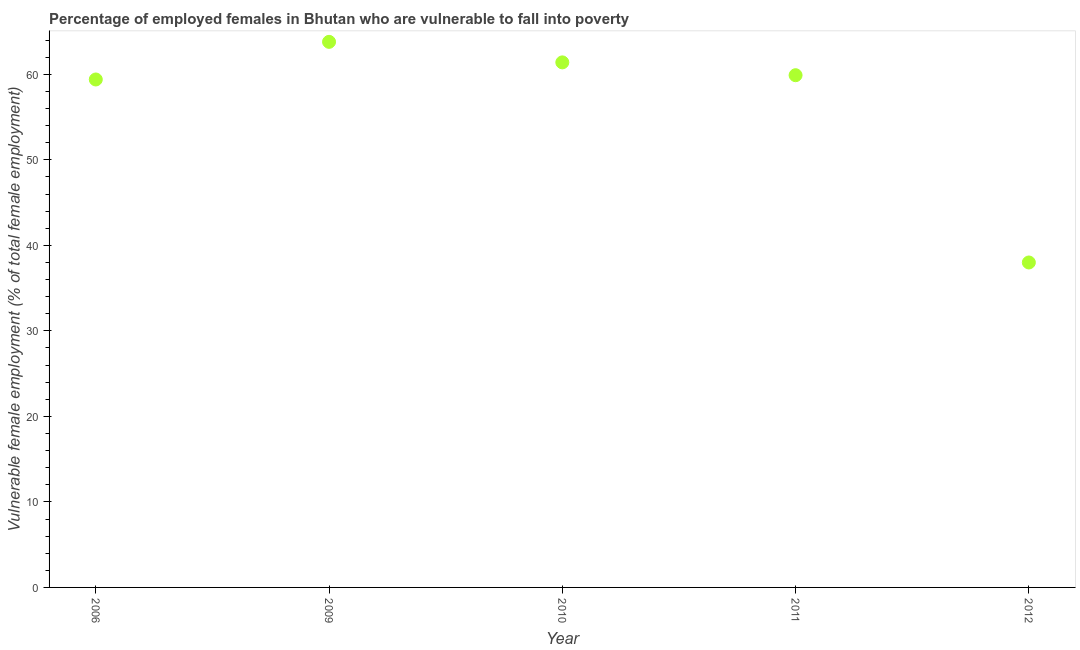What is the percentage of employed females who are vulnerable to fall into poverty in 2011?
Make the answer very short. 59.9. Across all years, what is the maximum percentage of employed females who are vulnerable to fall into poverty?
Give a very brief answer. 63.8. Across all years, what is the minimum percentage of employed females who are vulnerable to fall into poverty?
Ensure brevity in your answer.  38. In which year was the percentage of employed females who are vulnerable to fall into poverty maximum?
Make the answer very short. 2009. In which year was the percentage of employed females who are vulnerable to fall into poverty minimum?
Offer a terse response. 2012. What is the sum of the percentage of employed females who are vulnerable to fall into poverty?
Provide a short and direct response. 282.5. What is the difference between the percentage of employed females who are vulnerable to fall into poverty in 2011 and 2012?
Keep it short and to the point. 21.9. What is the average percentage of employed females who are vulnerable to fall into poverty per year?
Keep it short and to the point. 56.5. What is the median percentage of employed females who are vulnerable to fall into poverty?
Provide a short and direct response. 59.9. What is the ratio of the percentage of employed females who are vulnerable to fall into poverty in 2006 to that in 2011?
Your response must be concise. 0.99. Is the difference between the percentage of employed females who are vulnerable to fall into poverty in 2006 and 2010 greater than the difference between any two years?
Offer a very short reply. No. What is the difference between the highest and the second highest percentage of employed females who are vulnerable to fall into poverty?
Your answer should be very brief. 2.4. What is the difference between the highest and the lowest percentage of employed females who are vulnerable to fall into poverty?
Your answer should be compact. 25.8. How many years are there in the graph?
Provide a short and direct response. 5. What is the difference between two consecutive major ticks on the Y-axis?
Your answer should be very brief. 10. Are the values on the major ticks of Y-axis written in scientific E-notation?
Ensure brevity in your answer.  No. Does the graph contain any zero values?
Offer a very short reply. No. What is the title of the graph?
Keep it short and to the point. Percentage of employed females in Bhutan who are vulnerable to fall into poverty. What is the label or title of the X-axis?
Provide a succinct answer. Year. What is the label or title of the Y-axis?
Keep it short and to the point. Vulnerable female employment (% of total female employment). What is the Vulnerable female employment (% of total female employment) in 2006?
Offer a very short reply. 59.4. What is the Vulnerable female employment (% of total female employment) in 2009?
Offer a terse response. 63.8. What is the Vulnerable female employment (% of total female employment) in 2010?
Give a very brief answer. 61.4. What is the Vulnerable female employment (% of total female employment) in 2011?
Keep it short and to the point. 59.9. What is the Vulnerable female employment (% of total female employment) in 2012?
Provide a short and direct response. 38. What is the difference between the Vulnerable female employment (% of total female employment) in 2006 and 2012?
Make the answer very short. 21.4. What is the difference between the Vulnerable female employment (% of total female employment) in 2009 and 2012?
Provide a short and direct response. 25.8. What is the difference between the Vulnerable female employment (% of total female employment) in 2010 and 2012?
Give a very brief answer. 23.4. What is the difference between the Vulnerable female employment (% of total female employment) in 2011 and 2012?
Your answer should be very brief. 21.9. What is the ratio of the Vulnerable female employment (% of total female employment) in 2006 to that in 2009?
Provide a succinct answer. 0.93. What is the ratio of the Vulnerable female employment (% of total female employment) in 2006 to that in 2011?
Your answer should be very brief. 0.99. What is the ratio of the Vulnerable female employment (% of total female employment) in 2006 to that in 2012?
Your response must be concise. 1.56. What is the ratio of the Vulnerable female employment (% of total female employment) in 2009 to that in 2010?
Your response must be concise. 1.04. What is the ratio of the Vulnerable female employment (% of total female employment) in 2009 to that in 2011?
Provide a succinct answer. 1.06. What is the ratio of the Vulnerable female employment (% of total female employment) in 2009 to that in 2012?
Your answer should be compact. 1.68. What is the ratio of the Vulnerable female employment (% of total female employment) in 2010 to that in 2012?
Give a very brief answer. 1.62. What is the ratio of the Vulnerable female employment (% of total female employment) in 2011 to that in 2012?
Your answer should be very brief. 1.58. 